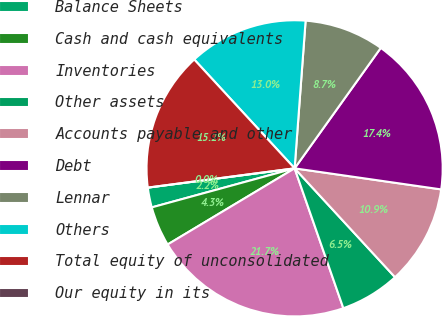<chart> <loc_0><loc_0><loc_500><loc_500><pie_chart><fcel>Balance Sheets<fcel>Cash and cash equivalents<fcel>Inventories<fcel>Other assets<fcel>Accounts payable and other<fcel>Debt<fcel>Lennar<fcel>Others<fcel>Total equity of unconsolidated<fcel>Our equity in its<nl><fcel>2.17%<fcel>4.35%<fcel>21.74%<fcel>6.52%<fcel>10.87%<fcel>17.39%<fcel>8.7%<fcel>13.04%<fcel>15.22%<fcel>0.0%<nl></chart> 